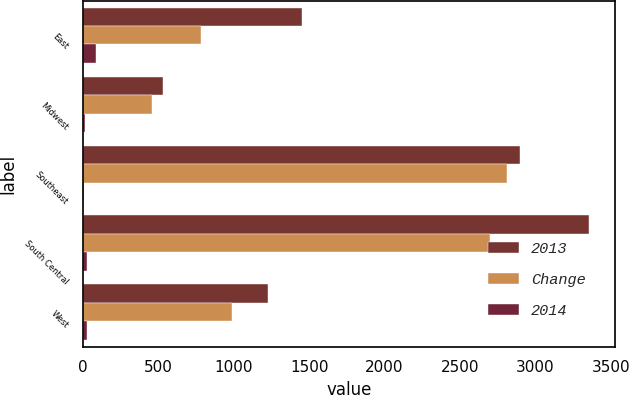<chart> <loc_0><loc_0><loc_500><loc_500><stacked_bar_chart><ecel><fcel>East<fcel>Midwest<fcel>Southeast<fcel>South Central<fcel>West<nl><fcel>2013<fcel>1451<fcel>527<fcel>2901<fcel>3358<fcel>1226<nl><fcel>Change<fcel>782<fcel>456<fcel>2810<fcel>2697<fcel>985<nl><fcel>2014<fcel>86<fcel>16<fcel>3<fcel>25<fcel>24<nl></chart> 